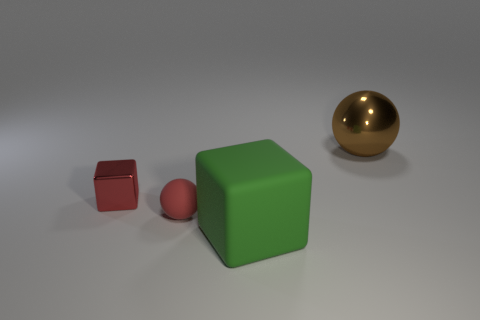Subtract all cyan balls. Subtract all yellow cylinders. How many balls are left? 2 Add 4 red matte things. How many objects exist? 8 Add 2 tiny metal objects. How many tiny metal objects are left? 3 Add 4 tiny red metallic objects. How many tiny red metallic objects exist? 5 Subtract 0 yellow cubes. How many objects are left? 4 Subtract all tiny red things. Subtract all big brown balls. How many objects are left? 1 